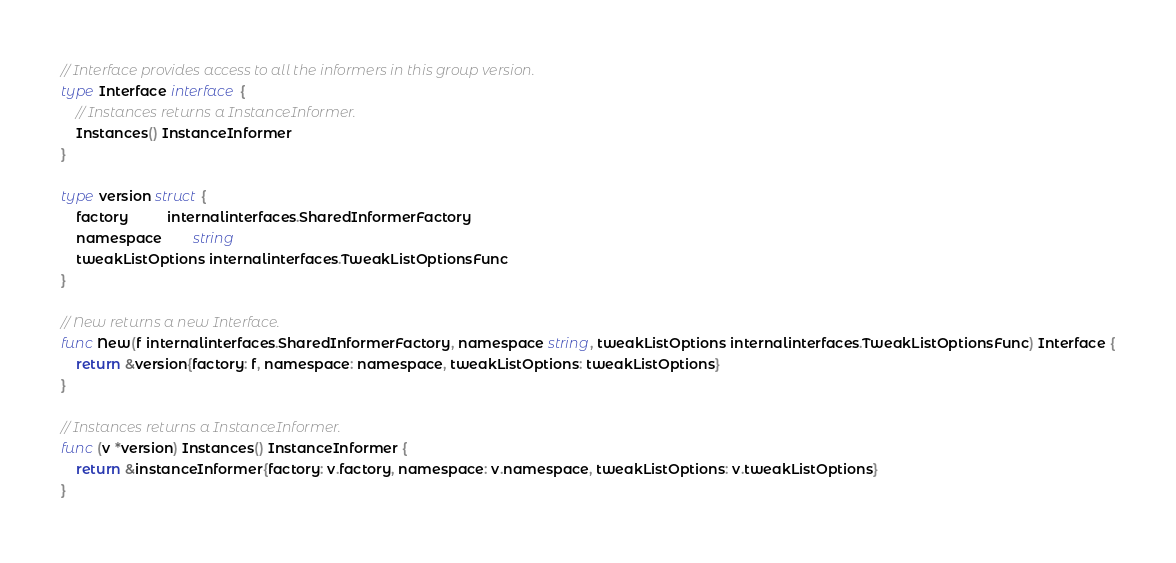<code> <loc_0><loc_0><loc_500><loc_500><_Go_>// Interface provides access to all the informers in this group version.
type Interface interface {
	// Instances returns a InstanceInformer.
	Instances() InstanceInformer
}

type version struct {
	factory          internalinterfaces.SharedInformerFactory
	namespace        string
	tweakListOptions internalinterfaces.TweakListOptionsFunc
}

// New returns a new Interface.
func New(f internalinterfaces.SharedInformerFactory, namespace string, tweakListOptions internalinterfaces.TweakListOptionsFunc) Interface {
	return &version{factory: f, namespace: namespace, tweakListOptions: tweakListOptions}
}

// Instances returns a InstanceInformer.
func (v *version) Instances() InstanceInformer {
	return &instanceInformer{factory: v.factory, namespace: v.namespace, tweakListOptions: v.tweakListOptions}
}
</code> 